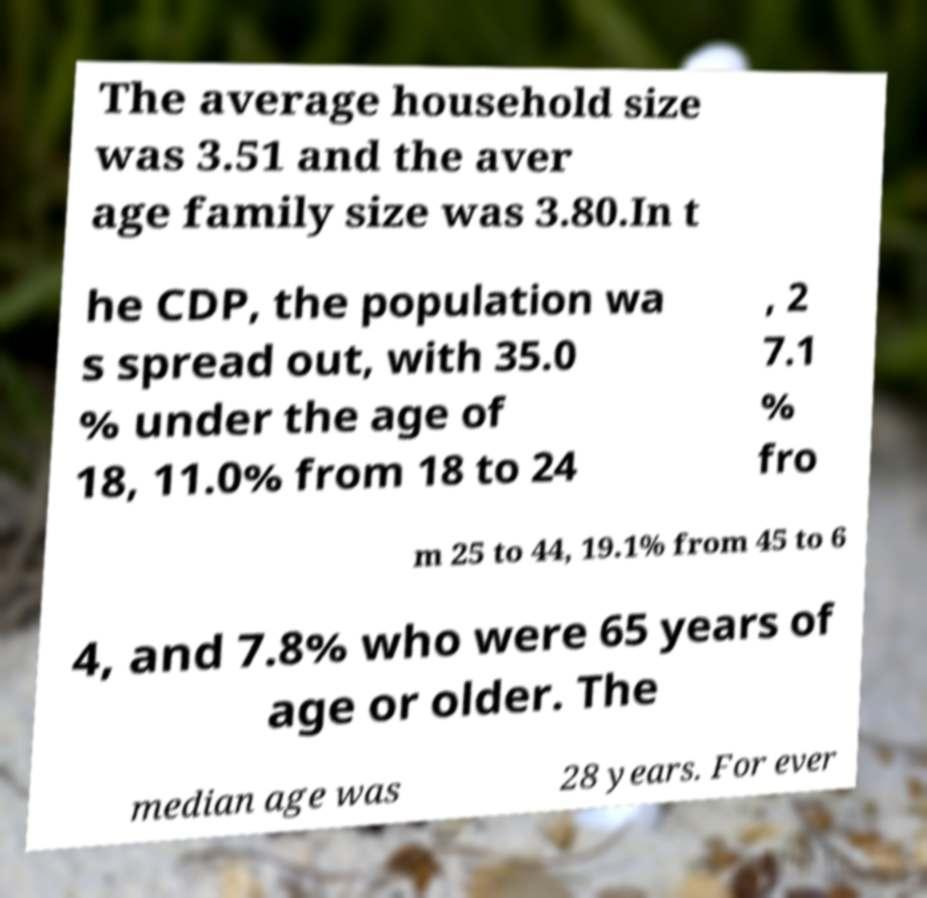I need the written content from this picture converted into text. Can you do that? The average household size was 3.51 and the aver age family size was 3.80.In t he CDP, the population wa s spread out, with 35.0 % under the age of 18, 11.0% from 18 to 24 , 2 7.1 % fro m 25 to 44, 19.1% from 45 to 6 4, and 7.8% who were 65 years of age or older. The median age was 28 years. For ever 